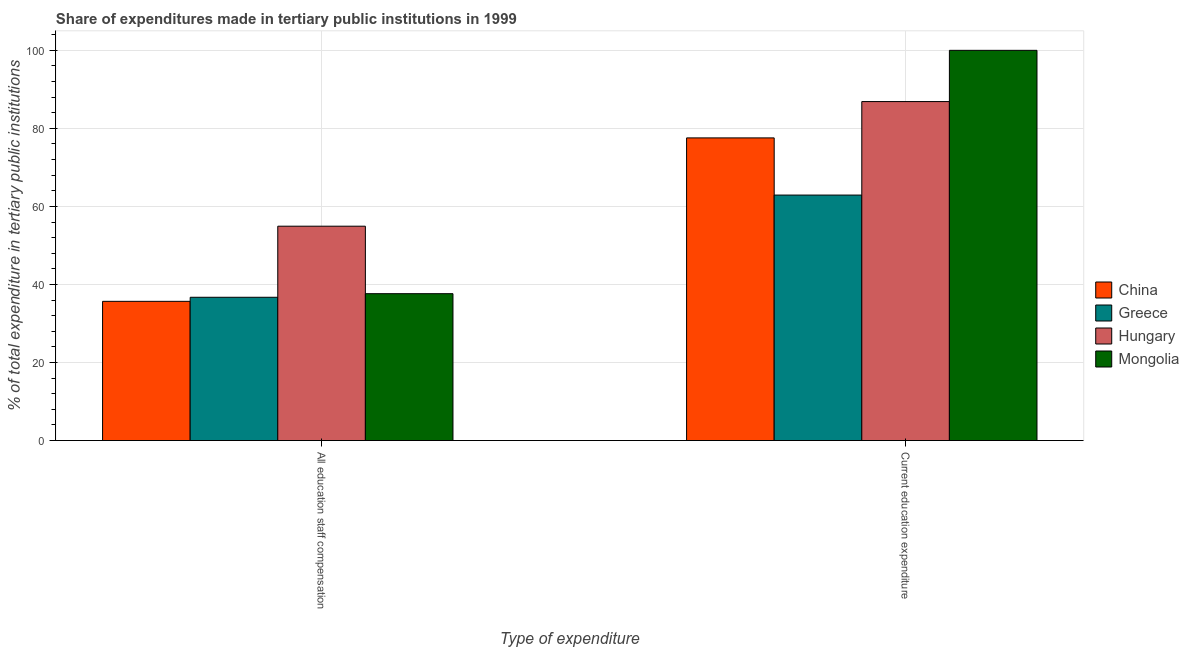How many different coloured bars are there?
Give a very brief answer. 4. Are the number of bars on each tick of the X-axis equal?
Provide a succinct answer. Yes. How many bars are there on the 2nd tick from the left?
Your answer should be very brief. 4. How many bars are there on the 2nd tick from the right?
Offer a terse response. 4. What is the label of the 2nd group of bars from the left?
Provide a succinct answer. Current education expenditure. What is the expenditure in staff compensation in Hungary?
Offer a terse response. 54.94. Across all countries, what is the maximum expenditure in education?
Ensure brevity in your answer.  100. Across all countries, what is the minimum expenditure in education?
Give a very brief answer. 62.91. In which country was the expenditure in education maximum?
Your answer should be very brief. Mongolia. In which country was the expenditure in education minimum?
Keep it short and to the point. Greece. What is the total expenditure in education in the graph?
Your response must be concise. 327.35. What is the difference between the expenditure in education in China and that in Mongolia?
Give a very brief answer. -22.44. What is the difference between the expenditure in staff compensation in Greece and the expenditure in education in Mongolia?
Offer a very short reply. -63.28. What is the average expenditure in education per country?
Offer a terse response. 81.84. What is the difference between the expenditure in education and expenditure in staff compensation in Greece?
Make the answer very short. 26.19. In how many countries, is the expenditure in education greater than 8 %?
Your answer should be very brief. 4. What is the ratio of the expenditure in staff compensation in Greece to that in China?
Give a very brief answer. 1.03. Is the expenditure in staff compensation in Greece less than that in China?
Make the answer very short. No. What does the 4th bar from the left in Current education expenditure represents?
Offer a terse response. Mongolia. What does the 2nd bar from the right in Current education expenditure represents?
Offer a very short reply. Hungary. Are all the bars in the graph horizontal?
Keep it short and to the point. No. What is the difference between two consecutive major ticks on the Y-axis?
Offer a very short reply. 20. Are the values on the major ticks of Y-axis written in scientific E-notation?
Your response must be concise. No. Does the graph contain any zero values?
Your response must be concise. No. Does the graph contain grids?
Your response must be concise. Yes. Where does the legend appear in the graph?
Keep it short and to the point. Center right. How many legend labels are there?
Offer a very short reply. 4. What is the title of the graph?
Provide a short and direct response. Share of expenditures made in tertiary public institutions in 1999. What is the label or title of the X-axis?
Give a very brief answer. Type of expenditure. What is the label or title of the Y-axis?
Provide a succinct answer. % of total expenditure in tertiary public institutions. What is the % of total expenditure in tertiary public institutions in China in All education staff compensation?
Give a very brief answer. 35.68. What is the % of total expenditure in tertiary public institutions in Greece in All education staff compensation?
Ensure brevity in your answer.  36.72. What is the % of total expenditure in tertiary public institutions in Hungary in All education staff compensation?
Provide a succinct answer. 54.94. What is the % of total expenditure in tertiary public institutions in Mongolia in All education staff compensation?
Make the answer very short. 37.64. What is the % of total expenditure in tertiary public institutions in China in Current education expenditure?
Your answer should be very brief. 77.56. What is the % of total expenditure in tertiary public institutions in Greece in Current education expenditure?
Give a very brief answer. 62.91. What is the % of total expenditure in tertiary public institutions in Hungary in Current education expenditure?
Offer a very short reply. 86.87. Across all Type of expenditure, what is the maximum % of total expenditure in tertiary public institutions in China?
Your answer should be compact. 77.56. Across all Type of expenditure, what is the maximum % of total expenditure in tertiary public institutions of Greece?
Your answer should be compact. 62.91. Across all Type of expenditure, what is the maximum % of total expenditure in tertiary public institutions in Hungary?
Provide a succinct answer. 86.87. Across all Type of expenditure, what is the maximum % of total expenditure in tertiary public institutions in Mongolia?
Provide a short and direct response. 100. Across all Type of expenditure, what is the minimum % of total expenditure in tertiary public institutions in China?
Make the answer very short. 35.68. Across all Type of expenditure, what is the minimum % of total expenditure in tertiary public institutions in Greece?
Make the answer very short. 36.72. Across all Type of expenditure, what is the minimum % of total expenditure in tertiary public institutions in Hungary?
Offer a terse response. 54.94. Across all Type of expenditure, what is the minimum % of total expenditure in tertiary public institutions of Mongolia?
Offer a very short reply. 37.64. What is the total % of total expenditure in tertiary public institutions in China in the graph?
Your answer should be very brief. 113.24. What is the total % of total expenditure in tertiary public institutions in Greece in the graph?
Make the answer very short. 99.64. What is the total % of total expenditure in tertiary public institutions of Hungary in the graph?
Offer a very short reply. 141.81. What is the total % of total expenditure in tertiary public institutions in Mongolia in the graph?
Ensure brevity in your answer.  137.64. What is the difference between the % of total expenditure in tertiary public institutions of China in All education staff compensation and that in Current education expenditure?
Your answer should be very brief. -41.88. What is the difference between the % of total expenditure in tertiary public institutions in Greece in All education staff compensation and that in Current education expenditure?
Your answer should be compact. -26.19. What is the difference between the % of total expenditure in tertiary public institutions in Hungary in All education staff compensation and that in Current education expenditure?
Give a very brief answer. -31.94. What is the difference between the % of total expenditure in tertiary public institutions of Mongolia in All education staff compensation and that in Current education expenditure?
Offer a very short reply. -62.36. What is the difference between the % of total expenditure in tertiary public institutions of China in All education staff compensation and the % of total expenditure in tertiary public institutions of Greece in Current education expenditure?
Your answer should be compact. -27.23. What is the difference between the % of total expenditure in tertiary public institutions of China in All education staff compensation and the % of total expenditure in tertiary public institutions of Hungary in Current education expenditure?
Offer a very short reply. -51.19. What is the difference between the % of total expenditure in tertiary public institutions in China in All education staff compensation and the % of total expenditure in tertiary public institutions in Mongolia in Current education expenditure?
Offer a terse response. -64.32. What is the difference between the % of total expenditure in tertiary public institutions in Greece in All education staff compensation and the % of total expenditure in tertiary public institutions in Hungary in Current education expenditure?
Ensure brevity in your answer.  -50.15. What is the difference between the % of total expenditure in tertiary public institutions of Greece in All education staff compensation and the % of total expenditure in tertiary public institutions of Mongolia in Current education expenditure?
Keep it short and to the point. -63.28. What is the difference between the % of total expenditure in tertiary public institutions in Hungary in All education staff compensation and the % of total expenditure in tertiary public institutions in Mongolia in Current education expenditure?
Keep it short and to the point. -45.06. What is the average % of total expenditure in tertiary public institutions of China per Type of expenditure?
Provide a short and direct response. 56.62. What is the average % of total expenditure in tertiary public institutions of Greece per Type of expenditure?
Ensure brevity in your answer.  49.82. What is the average % of total expenditure in tertiary public institutions of Hungary per Type of expenditure?
Your answer should be compact. 70.9. What is the average % of total expenditure in tertiary public institutions in Mongolia per Type of expenditure?
Offer a very short reply. 68.82. What is the difference between the % of total expenditure in tertiary public institutions of China and % of total expenditure in tertiary public institutions of Greece in All education staff compensation?
Keep it short and to the point. -1.04. What is the difference between the % of total expenditure in tertiary public institutions of China and % of total expenditure in tertiary public institutions of Hungary in All education staff compensation?
Offer a terse response. -19.26. What is the difference between the % of total expenditure in tertiary public institutions of China and % of total expenditure in tertiary public institutions of Mongolia in All education staff compensation?
Offer a very short reply. -1.96. What is the difference between the % of total expenditure in tertiary public institutions of Greece and % of total expenditure in tertiary public institutions of Hungary in All education staff compensation?
Keep it short and to the point. -18.21. What is the difference between the % of total expenditure in tertiary public institutions of Greece and % of total expenditure in tertiary public institutions of Mongolia in All education staff compensation?
Offer a very short reply. -0.92. What is the difference between the % of total expenditure in tertiary public institutions in Hungary and % of total expenditure in tertiary public institutions in Mongolia in All education staff compensation?
Offer a very short reply. 17.29. What is the difference between the % of total expenditure in tertiary public institutions in China and % of total expenditure in tertiary public institutions in Greece in Current education expenditure?
Offer a terse response. 14.65. What is the difference between the % of total expenditure in tertiary public institutions in China and % of total expenditure in tertiary public institutions in Hungary in Current education expenditure?
Offer a very short reply. -9.31. What is the difference between the % of total expenditure in tertiary public institutions of China and % of total expenditure in tertiary public institutions of Mongolia in Current education expenditure?
Your answer should be very brief. -22.44. What is the difference between the % of total expenditure in tertiary public institutions in Greece and % of total expenditure in tertiary public institutions in Hungary in Current education expenditure?
Provide a succinct answer. -23.96. What is the difference between the % of total expenditure in tertiary public institutions in Greece and % of total expenditure in tertiary public institutions in Mongolia in Current education expenditure?
Your response must be concise. -37.09. What is the difference between the % of total expenditure in tertiary public institutions in Hungary and % of total expenditure in tertiary public institutions in Mongolia in Current education expenditure?
Offer a very short reply. -13.13. What is the ratio of the % of total expenditure in tertiary public institutions in China in All education staff compensation to that in Current education expenditure?
Ensure brevity in your answer.  0.46. What is the ratio of the % of total expenditure in tertiary public institutions in Greece in All education staff compensation to that in Current education expenditure?
Offer a very short reply. 0.58. What is the ratio of the % of total expenditure in tertiary public institutions in Hungary in All education staff compensation to that in Current education expenditure?
Your answer should be compact. 0.63. What is the ratio of the % of total expenditure in tertiary public institutions of Mongolia in All education staff compensation to that in Current education expenditure?
Give a very brief answer. 0.38. What is the difference between the highest and the second highest % of total expenditure in tertiary public institutions in China?
Ensure brevity in your answer.  41.88. What is the difference between the highest and the second highest % of total expenditure in tertiary public institutions in Greece?
Your answer should be compact. 26.19. What is the difference between the highest and the second highest % of total expenditure in tertiary public institutions in Hungary?
Provide a short and direct response. 31.94. What is the difference between the highest and the second highest % of total expenditure in tertiary public institutions of Mongolia?
Offer a very short reply. 62.36. What is the difference between the highest and the lowest % of total expenditure in tertiary public institutions of China?
Your answer should be very brief. 41.88. What is the difference between the highest and the lowest % of total expenditure in tertiary public institutions of Greece?
Make the answer very short. 26.19. What is the difference between the highest and the lowest % of total expenditure in tertiary public institutions of Hungary?
Provide a succinct answer. 31.94. What is the difference between the highest and the lowest % of total expenditure in tertiary public institutions of Mongolia?
Your response must be concise. 62.36. 